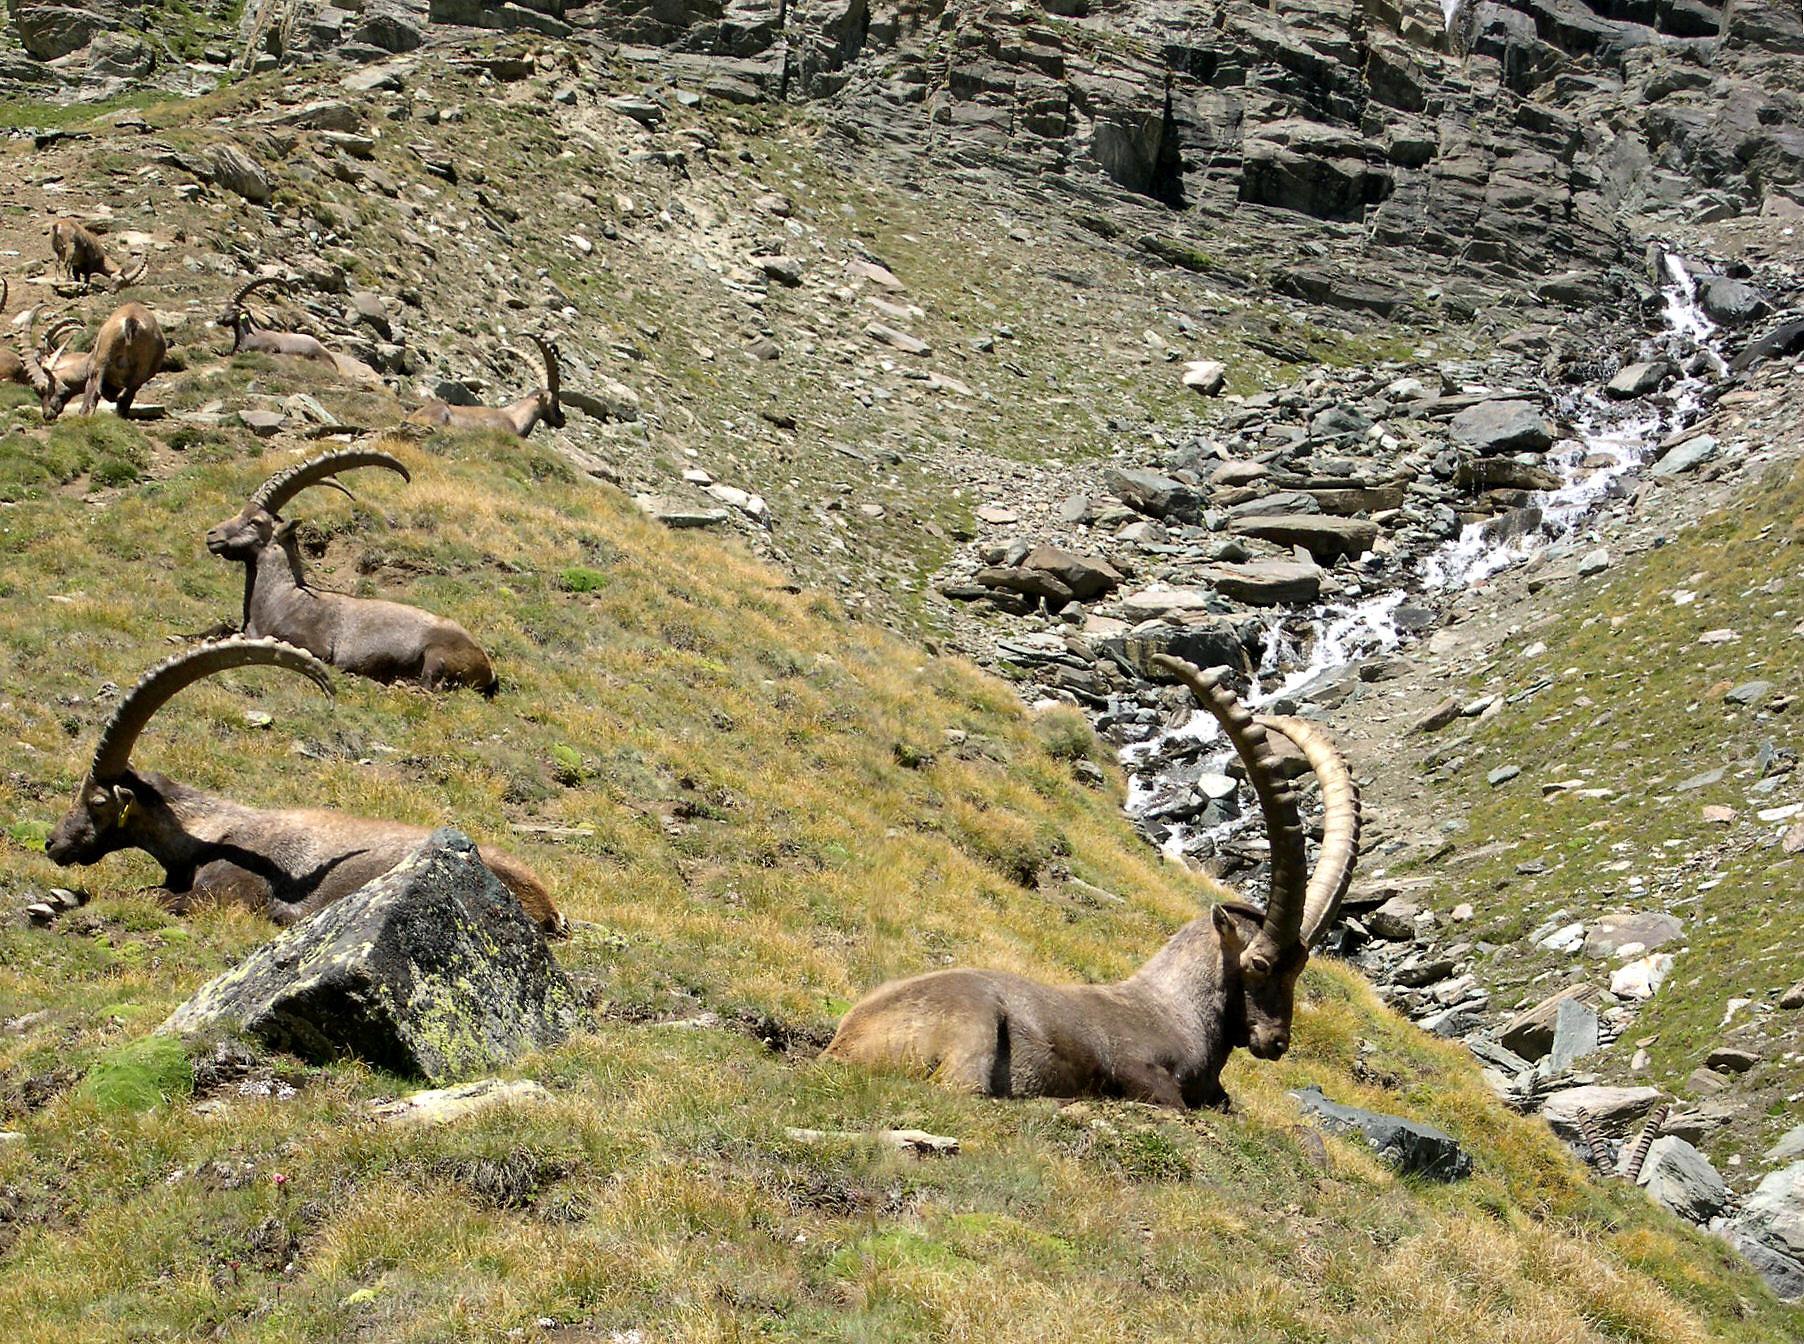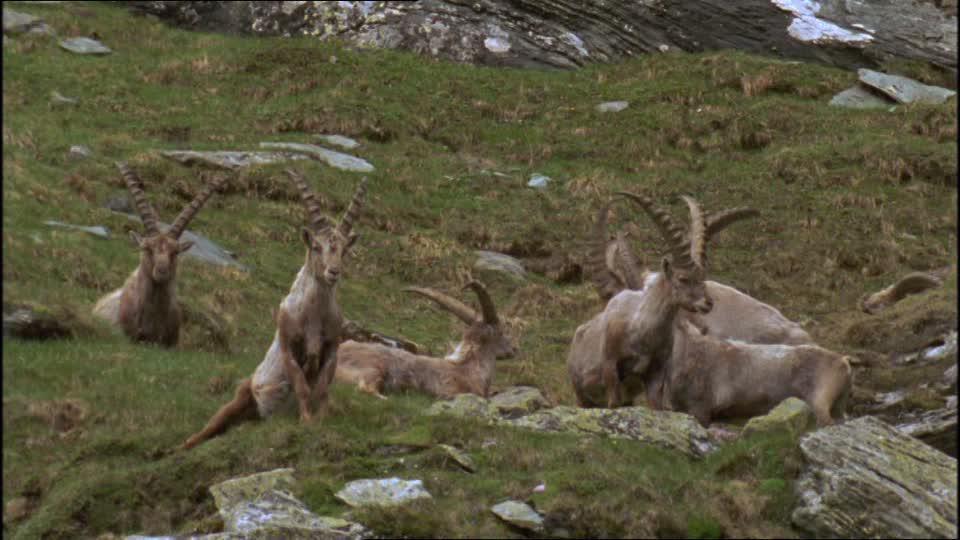The first image is the image on the left, the second image is the image on the right. For the images shown, is this caption "An area of sky blue is visible behind at least one mountain." true? Answer yes or no. No. The first image is the image on the left, the second image is the image on the right. Assess this claim about the two images: "At least one antelope is standing on a rocky grassless mountain.". Correct or not? Answer yes or no. No. 